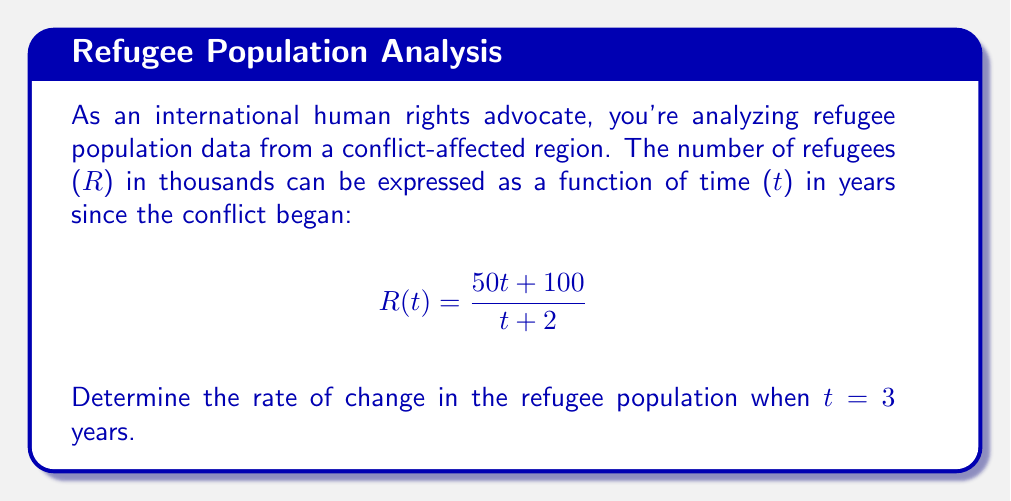Could you help me with this problem? To find the rate of change in the refugee population at t = 3 years, we need to calculate the derivative of R(t) and evaluate it at t = 3.

Step 1: Calculate the derivative of R(t) using the quotient rule.
Let $u = 50t + 100$ and $v = t + 2$
$$R'(t) = \frac{u'v - uv'}{v^2} = \frac{50(t+2) - (50t+100)(1)}{(t+2)^2}$$

Step 2: Simplify the numerator.
$$R'(t) = \frac{50t + 100 - 50t - 100}{(t+2)^2} = \frac{0}{(t+2)^2}$$

Step 3: Further simplify.
$$R'(t) = \frac{0}{(t+2)^2}$$

Step 4: Evaluate R'(t) at t = 3.
$$R'(3) = \frac{0}{(3+2)^2} = \frac{0}{25} = 0$$

The rate of change in the refugee population when t = 3 years is 0 thousand refugees per year.
Answer: 0 thousand refugees per year 